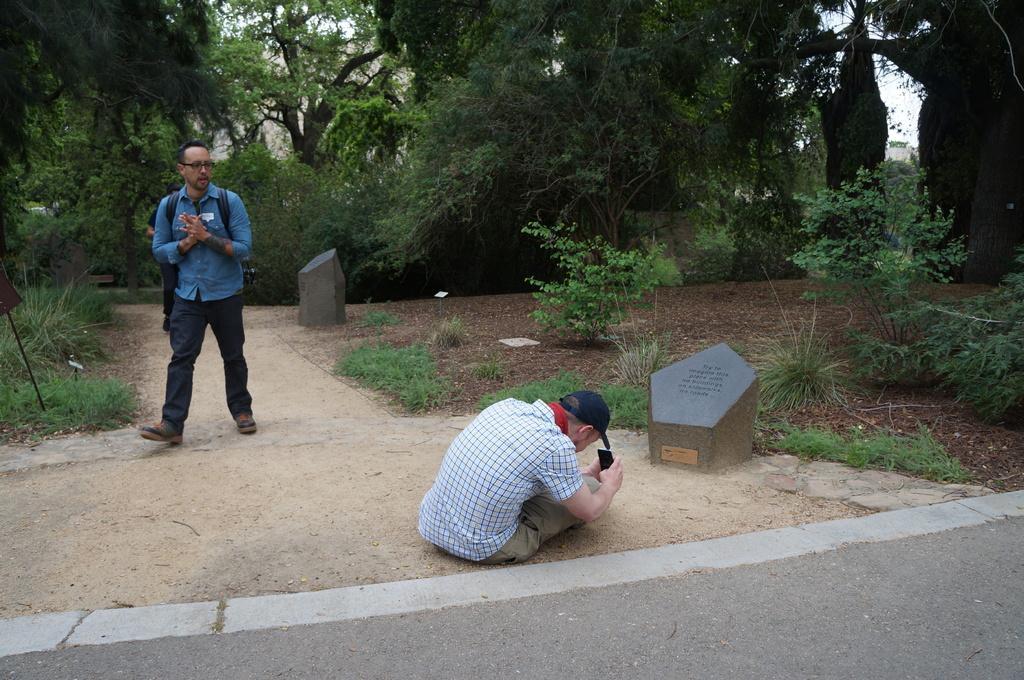Please provide a concise description of this image. In this image we can see a man sitting on the ground and he is capturing an image with a mobile phone. Here we can see a cap on his head. Here we can see another man walking and he is on the left side. Here we can see the trees on the left side and the right side as well. Here we can see the rocks. 